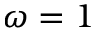Convert formula to latex. <formula><loc_0><loc_0><loc_500><loc_500>\omega = 1</formula> 